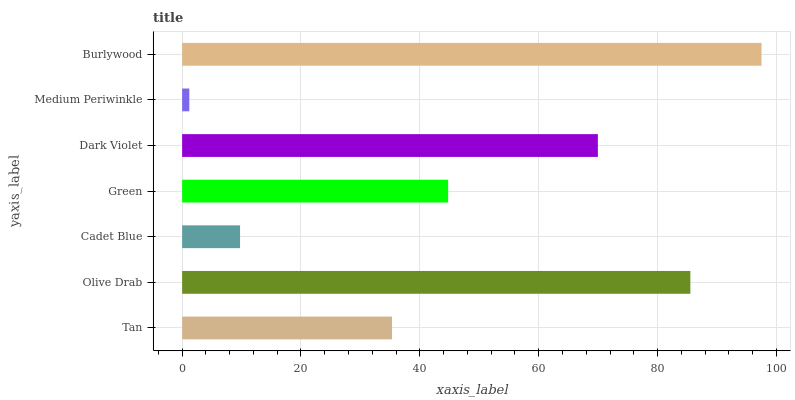Is Medium Periwinkle the minimum?
Answer yes or no. Yes. Is Burlywood the maximum?
Answer yes or no. Yes. Is Olive Drab the minimum?
Answer yes or no. No. Is Olive Drab the maximum?
Answer yes or no. No. Is Olive Drab greater than Tan?
Answer yes or no. Yes. Is Tan less than Olive Drab?
Answer yes or no. Yes. Is Tan greater than Olive Drab?
Answer yes or no. No. Is Olive Drab less than Tan?
Answer yes or no. No. Is Green the high median?
Answer yes or no. Yes. Is Green the low median?
Answer yes or no. Yes. Is Tan the high median?
Answer yes or no. No. Is Medium Periwinkle the low median?
Answer yes or no. No. 